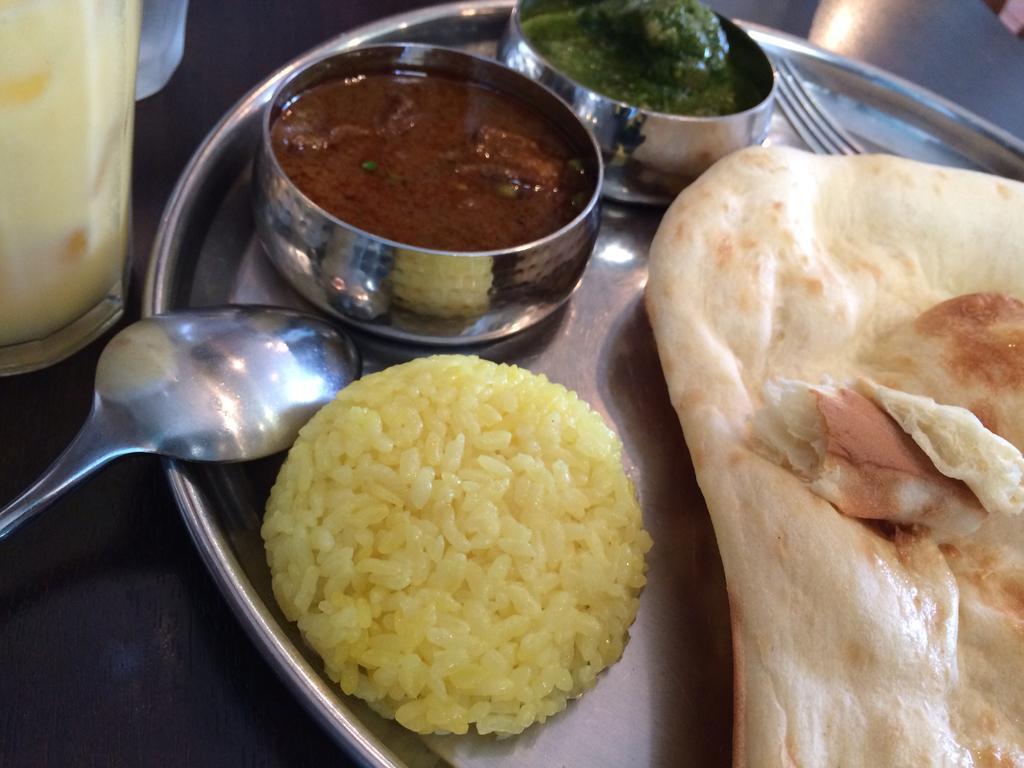In one or two sentences, can you explain what this image depicts? In this image we can see some food spoon, fork on the plate and on the left side we can see the glass. 